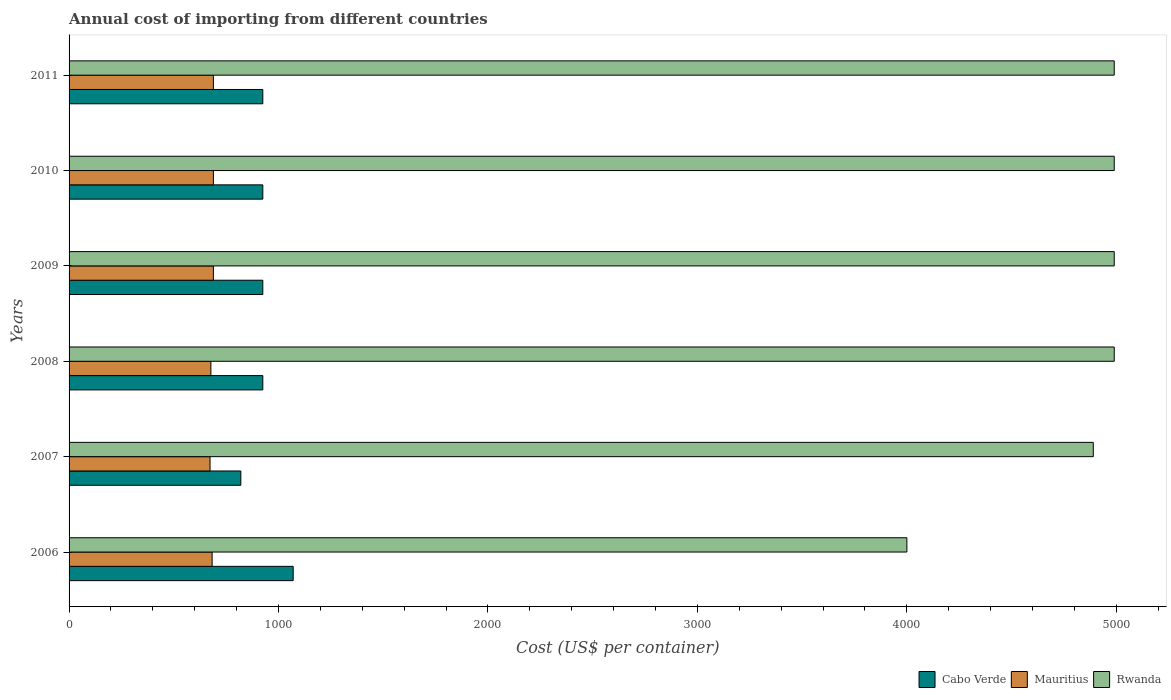In how many cases, is the number of bars for a given year not equal to the number of legend labels?
Your answer should be compact. 0. What is the total annual cost of importing in Rwanda in 2007?
Provide a succinct answer. 4890. Across all years, what is the maximum total annual cost of importing in Mauritius?
Offer a very short reply. 689. Across all years, what is the minimum total annual cost of importing in Mauritius?
Offer a very short reply. 673. In which year was the total annual cost of importing in Cabo Verde minimum?
Give a very brief answer. 2007. What is the total total annual cost of importing in Rwanda in the graph?
Your response must be concise. 2.88e+04. What is the difference between the total annual cost of importing in Rwanda in 2008 and the total annual cost of importing in Cabo Verde in 2007?
Your response must be concise. 4170. What is the average total annual cost of importing in Rwanda per year?
Your answer should be very brief. 4808.33. In the year 2011, what is the difference between the total annual cost of importing in Rwanda and total annual cost of importing in Cabo Verde?
Offer a very short reply. 4065. Is the total annual cost of importing in Mauritius in 2008 less than that in 2009?
Give a very brief answer. Yes. What is the difference between the highest and the second highest total annual cost of importing in Cabo Verde?
Offer a very short reply. 145. What is the difference between the highest and the lowest total annual cost of importing in Rwanda?
Your answer should be compact. 990. Is the sum of the total annual cost of importing in Rwanda in 2007 and 2008 greater than the maximum total annual cost of importing in Mauritius across all years?
Make the answer very short. Yes. What does the 2nd bar from the top in 2011 represents?
Your answer should be very brief. Mauritius. What does the 1st bar from the bottom in 2009 represents?
Give a very brief answer. Cabo Verde. Is it the case that in every year, the sum of the total annual cost of importing in Cabo Verde and total annual cost of importing in Rwanda is greater than the total annual cost of importing in Mauritius?
Make the answer very short. Yes. Are all the bars in the graph horizontal?
Provide a succinct answer. Yes. How many years are there in the graph?
Your answer should be compact. 6. What is the difference between two consecutive major ticks on the X-axis?
Provide a short and direct response. 1000. Does the graph contain any zero values?
Offer a very short reply. No. Where does the legend appear in the graph?
Make the answer very short. Bottom right. What is the title of the graph?
Your answer should be very brief. Annual cost of importing from different countries. What is the label or title of the X-axis?
Provide a short and direct response. Cost (US$ per container). What is the Cost (US$ per container) of Cabo Verde in 2006?
Make the answer very short. 1070. What is the Cost (US$ per container) of Mauritius in 2006?
Your response must be concise. 683. What is the Cost (US$ per container) of Rwanda in 2006?
Give a very brief answer. 4000. What is the Cost (US$ per container) of Cabo Verde in 2007?
Offer a very short reply. 820. What is the Cost (US$ per container) of Mauritius in 2007?
Ensure brevity in your answer.  673. What is the Cost (US$ per container) of Rwanda in 2007?
Offer a terse response. 4890. What is the Cost (US$ per container) in Cabo Verde in 2008?
Keep it short and to the point. 925. What is the Cost (US$ per container) of Mauritius in 2008?
Provide a succinct answer. 677. What is the Cost (US$ per container) in Rwanda in 2008?
Offer a very short reply. 4990. What is the Cost (US$ per container) in Cabo Verde in 2009?
Ensure brevity in your answer.  925. What is the Cost (US$ per container) in Mauritius in 2009?
Your answer should be very brief. 689. What is the Cost (US$ per container) of Rwanda in 2009?
Provide a succinct answer. 4990. What is the Cost (US$ per container) of Cabo Verde in 2010?
Keep it short and to the point. 925. What is the Cost (US$ per container) of Mauritius in 2010?
Your answer should be very brief. 689. What is the Cost (US$ per container) of Rwanda in 2010?
Ensure brevity in your answer.  4990. What is the Cost (US$ per container) in Cabo Verde in 2011?
Your answer should be very brief. 925. What is the Cost (US$ per container) of Mauritius in 2011?
Give a very brief answer. 689. What is the Cost (US$ per container) in Rwanda in 2011?
Your answer should be compact. 4990. Across all years, what is the maximum Cost (US$ per container) in Cabo Verde?
Provide a short and direct response. 1070. Across all years, what is the maximum Cost (US$ per container) in Mauritius?
Your response must be concise. 689. Across all years, what is the maximum Cost (US$ per container) of Rwanda?
Provide a succinct answer. 4990. Across all years, what is the minimum Cost (US$ per container) in Cabo Verde?
Offer a terse response. 820. Across all years, what is the minimum Cost (US$ per container) of Mauritius?
Offer a terse response. 673. Across all years, what is the minimum Cost (US$ per container) of Rwanda?
Provide a succinct answer. 4000. What is the total Cost (US$ per container) of Cabo Verde in the graph?
Give a very brief answer. 5590. What is the total Cost (US$ per container) in Mauritius in the graph?
Your answer should be compact. 4100. What is the total Cost (US$ per container) of Rwanda in the graph?
Your answer should be compact. 2.88e+04. What is the difference between the Cost (US$ per container) of Cabo Verde in 2006 and that in 2007?
Ensure brevity in your answer.  250. What is the difference between the Cost (US$ per container) in Mauritius in 2006 and that in 2007?
Keep it short and to the point. 10. What is the difference between the Cost (US$ per container) of Rwanda in 2006 and that in 2007?
Your response must be concise. -890. What is the difference between the Cost (US$ per container) in Cabo Verde in 2006 and that in 2008?
Give a very brief answer. 145. What is the difference between the Cost (US$ per container) of Rwanda in 2006 and that in 2008?
Ensure brevity in your answer.  -990. What is the difference between the Cost (US$ per container) in Cabo Verde in 2006 and that in 2009?
Your response must be concise. 145. What is the difference between the Cost (US$ per container) in Rwanda in 2006 and that in 2009?
Your response must be concise. -990. What is the difference between the Cost (US$ per container) of Cabo Verde in 2006 and that in 2010?
Your answer should be compact. 145. What is the difference between the Cost (US$ per container) of Mauritius in 2006 and that in 2010?
Provide a short and direct response. -6. What is the difference between the Cost (US$ per container) in Rwanda in 2006 and that in 2010?
Offer a terse response. -990. What is the difference between the Cost (US$ per container) in Cabo Verde in 2006 and that in 2011?
Offer a terse response. 145. What is the difference between the Cost (US$ per container) of Rwanda in 2006 and that in 2011?
Give a very brief answer. -990. What is the difference between the Cost (US$ per container) in Cabo Verde in 2007 and that in 2008?
Provide a succinct answer. -105. What is the difference between the Cost (US$ per container) of Rwanda in 2007 and that in 2008?
Give a very brief answer. -100. What is the difference between the Cost (US$ per container) of Cabo Verde in 2007 and that in 2009?
Provide a short and direct response. -105. What is the difference between the Cost (US$ per container) of Rwanda in 2007 and that in 2009?
Offer a very short reply. -100. What is the difference between the Cost (US$ per container) of Cabo Verde in 2007 and that in 2010?
Keep it short and to the point. -105. What is the difference between the Cost (US$ per container) of Mauritius in 2007 and that in 2010?
Your answer should be compact. -16. What is the difference between the Cost (US$ per container) in Rwanda in 2007 and that in 2010?
Your answer should be very brief. -100. What is the difference between the Cost (US$ per container) in Cabo Verde in 2007 and that in 2011?
Your answer should be compact. -105. What is the difference between the Cost (US$ per container) of Mauritius in 2007 and that in 2011?
Provide a succinct answer. -16. What is the difference between the Cost (US$ per container) of Rwanda in 2007 and that in 2011?
Give a very brief answer. -100. What is the difference between the Cost (US$ per container) of Cabo Verde in 2008 and that in 2009?
Provide a succinct answer. 0. What is the difference between the Cost (US$ per container) in Rwanda in 2008 and that in 2009?
Your answer should be compact. 0. What is the difference between the Cost (US$ per container) of Cabo Verde in 2008 and that in 2010?
Keep it short and to the point. 0. What is the difference between the Cost (US$ per container) in Mauritius in 2008 and that in 2010?
Make the answer very short. -12. What is the difference between the Cost (US$ per container) in Mauritius in 2008 and that in 2011?
Give a very brief answer. -12. What is the difference between the Cost (US$ per container) in Rwanda in 2008 and that in 2011?
Your answer should be compact. 0. What is the difference between the Cost (US$ per container) of Cabo Verde in 2009 and that in 2010?
Offer a very short reply. 0. What is the difference between the Cost (US$ per container) of Mauritius in 2009 and that in 2011?
Keep it short and to the point. 0. What is the difference between the Cost (US$ per container) in Rwanda in 2010 and that in 2011?
Ensure brevity in your answer.  0. What is the difference between the Cost (US$ per container) in Cabo Verde in 2006 and the Cost (US$ per container) in Mauritius in 2007?
Your response must be concise. 397. What is the difference between the Cost (US$ per container) in Cabo Verde in 2006 and the Cost (US$ per container) in Rwanda in 2007?
Offer a terse response. -3820. What is the difference between the Cost (US$ per container) in Mauritius in 2006 and the Cost (US$ per container) in Rwanda in 2007?
Make the answer very short. -4207. What is the difference between the Cost (US$ per container) of Cabo Verde in 2006 and the Cost (US$ per container) of Mauritius in 2008?
Provide a succinct answer. 393. What is the difference between the Cost (US$ per container) in Cabo Verde in 2006 and the Cost (US$ per container) in Rwanda in 2008?
Give a very brief answer. -3920. What is the difference between the Cost (US$ per container) in Mauritius in 2006 and the Cost (US$ per container) in Rwanda in 2008?
Provide a succinct answer. -4307. What is the difference between the Cost (US$ per container) in Cabo Verde in 2006 and the Cost (US$ per container) in Mauritius in 2009?
Your answer should be very brief. 381. What is the difference between the Cost (US$ per container) in Cabo Verde in 2006 and the Cost (US$ per container) in Rwanda in 2009?
Your response must be concise. -3920. What is the difference between the Cost (US$ per container) of Mauritius in 2006 and the Cost (US$ per container) of Rwanda in 2009?
Provide a succinct answer. -4307. What is the difference between the Cost (US$ per container) in Cabo Verde in 2006 and the Cost (US$ per container) in Mauritius in 2010?
Keep it short and to the point. 381. What is the difference between the Cost (US$ per container) in Cabo Verde in 2006 and the Cost (US$ per container) in Rwanda in 2010?
Your answer should be compact. -3920. What is the difference between the Cost (US$ per container) in Mauritius in 2006 and the Cost (US$ per container) in Rwanda in 2010?
Make the answer very short. -4307. What is the difference between the Cost (US$ per container) in Cabo Verde in 2006 and the Cost (US$ per container) in Mauritius in 2011?
Keep it short and to the point. 381. What is the difference between the Cost (US$ per container) in Cabo Verde in 2006 and the Cost (US$ per container) in Rwanda in 2011?
Your response must be concise. -3920. What is the difference between the Cost (US$ per container) of Mauritius in 2006 and the Cost (US$ per container) of Rwanda in 2011?
Your response must be concise. -4307. What is the difference between the Cost (US$ per container) of Cabo Verde in 2007 and the Cost (US$ per container) of Mauritius in 2008?
Your answer should be very brief. 143. What is the difference between the Cost (US$ per container) in Cabo Verde in 2007 and the Cost (US$ per container) in Rwanda in 2008?
Provide a succinct answer. -4170. What is the difference between the Cost (US$ per container) in Mauritius in 2007 and the Cost (US$ per container) in Rwanda in 2008?
Offer a terse response. -4317. What is the difference between the Cost (US$ per container) in Cabo Verde in 2007 and the Cost (US$ per container) in Mauritius in 2009?
Give a very brief answer. 131. What is the difference between the Cost (US$ per container) of Cabo Verde in 2007 and the Cost (US$ per container) of Rwanda in 2009?
Your answer should be very brief. -4170. What is the difference between the Cost (US$ per container) of Mauritius in 2007 and the Cost (US$ per container) of Rwanda in 2009?
Ensure brevity in your answer.  -4317. What is the difference between the Cost (US$ per container) of Cabo Verde in 2007 and the Cost (US$ per container) of Mauritius in 2010?
Keep it short and to the point. 131. What is the difference between the Cost (US$ per container) of Cabo Verde in 2007 and the Cost (US$ per container) of Rwanda in 2010?
Offer a very short reply. -4170. What is the difference between the Cost (US$ per container) of Mauritius in 2007 and the Cost (US$ per container) of Rwanda in 2010?
Offer a very short reply. -4317. What is the difference between the Cost (US$ per container) in Cabo Verde in 2007 and the Cost (US$ per container) in Mauritius in 2011?
Give a very brief answer. 131. What is the difference between the Cost (US$ per container) of Cabo Verde in 2007 and the Cost (US$ per container) of Rwanda in 2011?
Give a very brief answer. -4170. What is the difference between the Cost (US$ per container) in Mauritius in 2007 and the Cost (US$ per container) in Rwanda in 2011?
Offer a very short reply. -4317. What is the difference between the Cost (US$ per container) in Cabo Verde in 2008 and the Cost (US$ per container) in Mauritius in 2009?
Provide a short and direct response. 236. What is the difference between the Cost (US$ per container) in Cabo Verde in 2008 and the Cost (US$ per container) in Rwanda in 2009?
Your answer should be compact. -4065. What is the difference between the Cost (US$ per container) in Mauritius in 2008 and the Cost (US$ per container) in Rwanda in 2009?
Offer a very short reply. -4313. What is the difference between the Cost (US$ per container) of Cabo Verde in 2008 and the Cost (US$ per container) of Mauritius in 2010?
Make the answer very short. 236. What is the difference between the Cost (US$ per container) in Cabo Verde in 2008 and the Cost (US$ per container) in Rwanda in 2010?
Offer a terse response. -4065. What is the difference between the Cost (US$ per container) in Mauritius in 2008 and the Cost (US$ per container) in Rwanda in 2010?
Give a very brief answer. -4313. What is the difference between the Cost (US$ per container) in Cabo Verde in 2008 and the Cost (US$ per container) in Mauritius in 2011?
Offer a terse response. 236. What is the difference between the Cost (US$ per container) in Cabo Verde in 2008 and the Cost (US$ per container) in Rwanda in 2011?
Offer a very short reply. -4065. What is the difference between the Cost (US$ per container) of Mauritius in 2008 and the Cost (US$ per container) of Rwanda in 2011?
Offer a very short reply. -4313. What is the difference between the Cost (US$ per container) in Cabo Verde in 2009 and the Cost (US$ per container) in Mauritius in 2010?
Give a very brief answer. 236. What is the difference between the Cost (US$ per container) in Cabo Verde in 2009 and the Cost (US$ per container) in Rwanda in 2010?
Your answer should be very brief. -4065. What is the difference between the Cost (US$ per container) in Mauritius in 2009 and the Cost (US$ per container) in Rwanda in 2010?
Give a very brief answer. -4301. What is the difference between the Cost (US$ per container) in Cabo Verde in 2009 and the Cost (US$ per container) in Mauritius in 2011?
Your answer should be compact. 236. What is the difference between the Cost (US$ per container) of Cabo Verde in 2009 and the Cost (US$ per container) of Rwanda in 2011?
Ensure brevity in your answer.  -4065. What is the difference between the Cost (US$ per container) in Mauritius in 2009 and the Cost (US$ per container) in Rwanda in 2011?
Offer a very short reply. -4301. What is the difference between the Cost (US$ per container) in Cabo Verde in 2010 and the Cost (US$ per container) in Mauritius in 2011?
Give a very brief answer. 236. What is the difference between the Cost (US$ per container) in Cabo Verde in 2010 and the Cost (US$ per container) in Rwanda in 2011?
Offer a terse response. -4065. What is the difference between the Cost (US$ per container) of Mauritius in 2010 and the Cost (US$ per container) of Rwanda in 2011?
Provide a short and direct response. -4301. What is the average Cost (US$ per container) in Cabo Verde per year?
Offer a terse response. 931.67. What is the average Cost (US$ per container) in Mauritius per year?
Your answer should be compact. 683.33. What is the average Cost (US$ per container) of Rwanda per year?
Your answer should be compact. 4808.33. In the year 2006, what is the difference between the Cost (US$ per container) of Cabo Verde and Cost (US$ per container) of Mauritius?
Your answer should be compact. 387. In the year 2006, what is the difference between the Cost (US$ per container) in Cabo Verde and Cost (US$ per container) in Rwanda?
Offer a terse response. -2930. In the year 2006, what is the difference between the Cost (US$ per container) of Mauritius and Cost (US$ per container) of Rwanda?
Your answer should be compact. -3317. In the year 2007, what is the difference between the Cost (US$ per container) of Cabo Verde and Cost (US$ per container) of Mauritius?
Make the answer very short. 147. In the year 2007, what is the difference between the Cost (US$ per container) in Cabo Verde and Cost (US$ per container) in Rwanda?
Your answer should be compact. -4070. In the year 2007, what is the difference between the Cost (US$ per container) of Mauritius and Cost (US$ per container) of Rwanda?
Your answer should be very brief. -4217. In the year 2008, what is the difference between the Cost (US$ per container) in Cabo Verde and Cost (US$ per container) in Mauritius?
Give a very brief answer. 248. In the year 2008, what is the difference between the Cost (US$ per container) in Cabo Verde and Cost (US$ per container) in Rwanda?
Give a very brief answer. -4065. In the year 2008, what is the difference between the Cost (US$ per container) in Mauritius and Cost (US$ per container) in Rwanda?
Ensure brevity in your answer.  -4313. In the year 2009, what is the difference between the Cost (US$ per container) of Cabo Verde and Cost (US$ per container) of Mauritius?
Provide a succinct answer. 236. In the year 2009, what is the difference between the Cost (US$ per container) in Cabo Verde and Cost (US$ per container) in Rwanda?
Provide a succinct answer. -4065. In the year 2009, what is the difference between the Cost (US$ per container) in Mauritius and Cost (US$ per container) in Rwanda?
Your answer should be very brief. -4301. In the year 2010, what is the difference between the Cost (US$ per container) in Cabo Verde and Cost (US$ per container) in Mauritius?
Your answer should be compact. 236. In the year 2010, what is the difference between the Cost (US$ per container) of Cabo Verde and Cost (US$ per container) of Rwanda?
Your answer should be compact. -4065. In the year 2010, what is the difference between the Cost (US$ per container) in Mauritius and Cost (US$ per container) in Rwanda?
Your response must be concise. -4301. In the year 2011, what is the difference between the Cost (US$ per container) of Cabo Verde and Cost (US$ per container) of Mauritius?
Make the answer very short. 236. In the year 2011, what is the difference between the Cost (US$ per container) of Cabo Verde and Cost (US$ per container) of Rwanda?
Your answer should be compact. -4065. In the year 2011, what is the difference between the Cost (US$ per container) of Mauritius and Cost (US$ per container) of Rwanda?
Make the answer very short. -4301. What is the ratio of the Cost (US$ per container) of Cabo Verde in 2006 to that in 2007?
Keep it short and to the point. 1.3. What is the ratio of the Cost (US$ per container) in Mauritius in 2006 to that in 2007?
Offer a terse response. 1.01. What is the ratio of the Cost (US$ per container) in Rwanda in 2006 to that in 2007?
Keep it short and to the point. 0.82. What is the ratio of the Cost (US$ per container) of Cabo Verde in 2006 to that in 2008?
Your answer should be compact. 1.16. What is the ratio of the Cost (US$ per container) in Mauritius in 2006 to that in 2008?
Provide a short and direct response. 1.01. What is the ratio of the Cost (US$ per container) in Rwanda in 2006 to that in 2008?
Ensure brevity in your answer.  0.8. What is the ratio of the Cost (US$ per container) of Cabo Verde in 2006 to that in 2009?
Make the answer very short. 1.16. What is the ratio of the Cost (US$ per container) of Rwanda in 2006 to that in 2009?
Your answer should be compact. 0.8. What is the ratio of the Cost (US$ per container) of Cabo Verde in 2006 to that in 2010?
Your response must be concise. 1.16. What is the ratio of the Cost (US$ per container) of Rwanda in 2006 to that in 2010?
Provide a short and direct response. 0.8. What is the ratio of the Cost (US$ per container) in Cabo Verde in 2006 to that in 2011?
Keep it short and to the point. 1.16. What is the ratio of the Cost (US$ per container) of Mauritius in 2006 to that in 2011?
Your answer should be compact. 0.99. What is the ratio of the Cost (US$ per container) in Rwanda in 2006 to that in 2011?
Give a very brief answer. 0.8. What is the ratio of the Cost (US$ per container) of Cabo Verde in 2007 to that in 2008?
Offer a terse response. 0.89. What is the ratio of the Cost (US$ per container) of Cabo Verde in 2007 to that in 2009?
Your answer should be very brief. 0.89. What is the ratio of the Cost (US$ per container) of Mauritius in 2007 to that in 2009?
Ensure brevity in your answer.  0.98. What is the ratio of the Cost (US$ per container) of Rwanda in 2007 to that in 2009?
Your response must be concise. 0.98. What is the ratio of the Cost (US$ per container) of Cabo Verde in 2007 to that in 2010?
Ensure brevity in your answer.  0.89. What is the ratio of the Cost (US$ per container) in Mauritius in 2007 to that in 2010?
Give a very brief answer. 0.98. What is the ratio of the Cost (US$ per container) in Cabo Verde in 2007 to that in 2011?
Your answer should be compact. 0.89. What is the ratio of the Cost (US$ per container) of Mauritius in 2007 to that in 2011?
Make the answer very short. 0.98. What is the ratio of the Cost (US$ per container) in Rwanda in 2007 to that in 2011?
Provide a succinct answer. 0.98. What is the ratio of the Cost (US$ per container) of Mauritius in 2008 to that in 2009?
Give a very brief answer. 0.98. What is the ratio of the Cost (US$ per container) of Rwanda in 2008 to that in 2009?
Offer a very short reply. 1. What is the ratio of the Cost (US$ per container) of Cabo Verde in 2008 to that in 2010?
Your response must be concise. 1. What is the ratio of the Cost (US$ per container) in Mauritius in 2008 to that in 2010?
Your answer should be compact. 0.98. What is the ratio of the Cost (US$ per container) of Rwanda in 2008 to that in 2010?
Make the answer very short. 1. What is the ratio of the Cost (US$ per container) of Cabo Verde in 2008 to that in 2011?
Keep it short and to the point. 1. What is the ratio of the Cost (US$ per container) in Mauritius in 2008 to that in 2011?
Keep it short and to the point. 0.98. What is the ratio of the Cost (US$ per container) in Mauritius in 2009 to that in 2010?
Ensure brevity in your answer.  1. What is the ratio of the Cost (US$ per container) in Rwanda in 2009 to that in 2010?
Provide a short and direct response. 1. What is the ratio of the Cost (US$ per container) in Rwanda in 2009 to that in 2011?
Provide a short and direct response. 1. What is the ratio of the Cost (US$ per container) in Cabo Verde in 2010 to that in 2011?
Your answer should be compact. 1. What is the ratio of the Cost (US$ per container) in Mauritius in 2010 to that in 2011?
Your answer should be very brief. 1. What is the ratio of the Cost (US$ per container) of Rwanda in 2010 to that in 2011?
Your response must be concise. 1. What is the difference between the highest and the second highest Cost (US$ per container) in Cabo Verde?
Your response must be concise. 145. What is the difference between the highest and the second highest Cost (US$ per container) in Mauritius?
Your answer should be very brief. 0. What is the difference between the highest and the lowest Cost (US$ per container) in Cabo Verde?
Keep it short and to the point. 250. What is the difference between the highest and the lowest Cost (US$ per container) of Rwanda?
Provide a short and direct response. 990. 